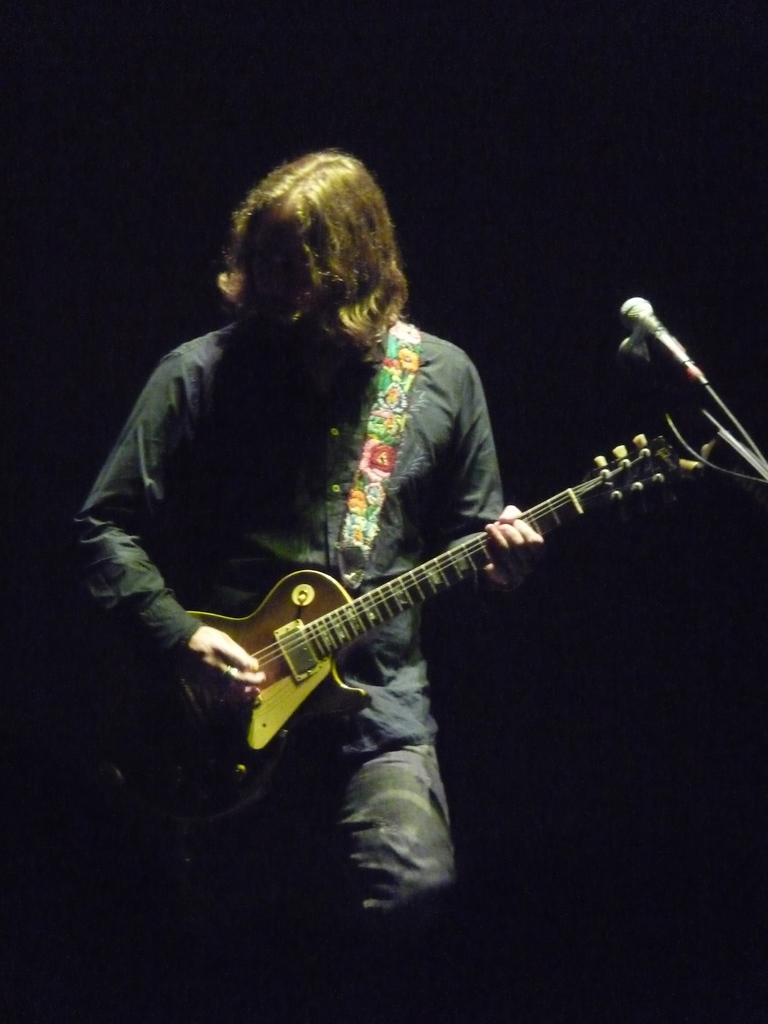What is the person in the image doing? The person is playing a guitar. What object is in front of the person? There is a microphone in front of the person. What type of pot is the person using to play the guitar in the image? There is no pot present in the image, and the person is not using any pot to play the guitar. How many needles can be seen in the image? There are no needles present in the image. 